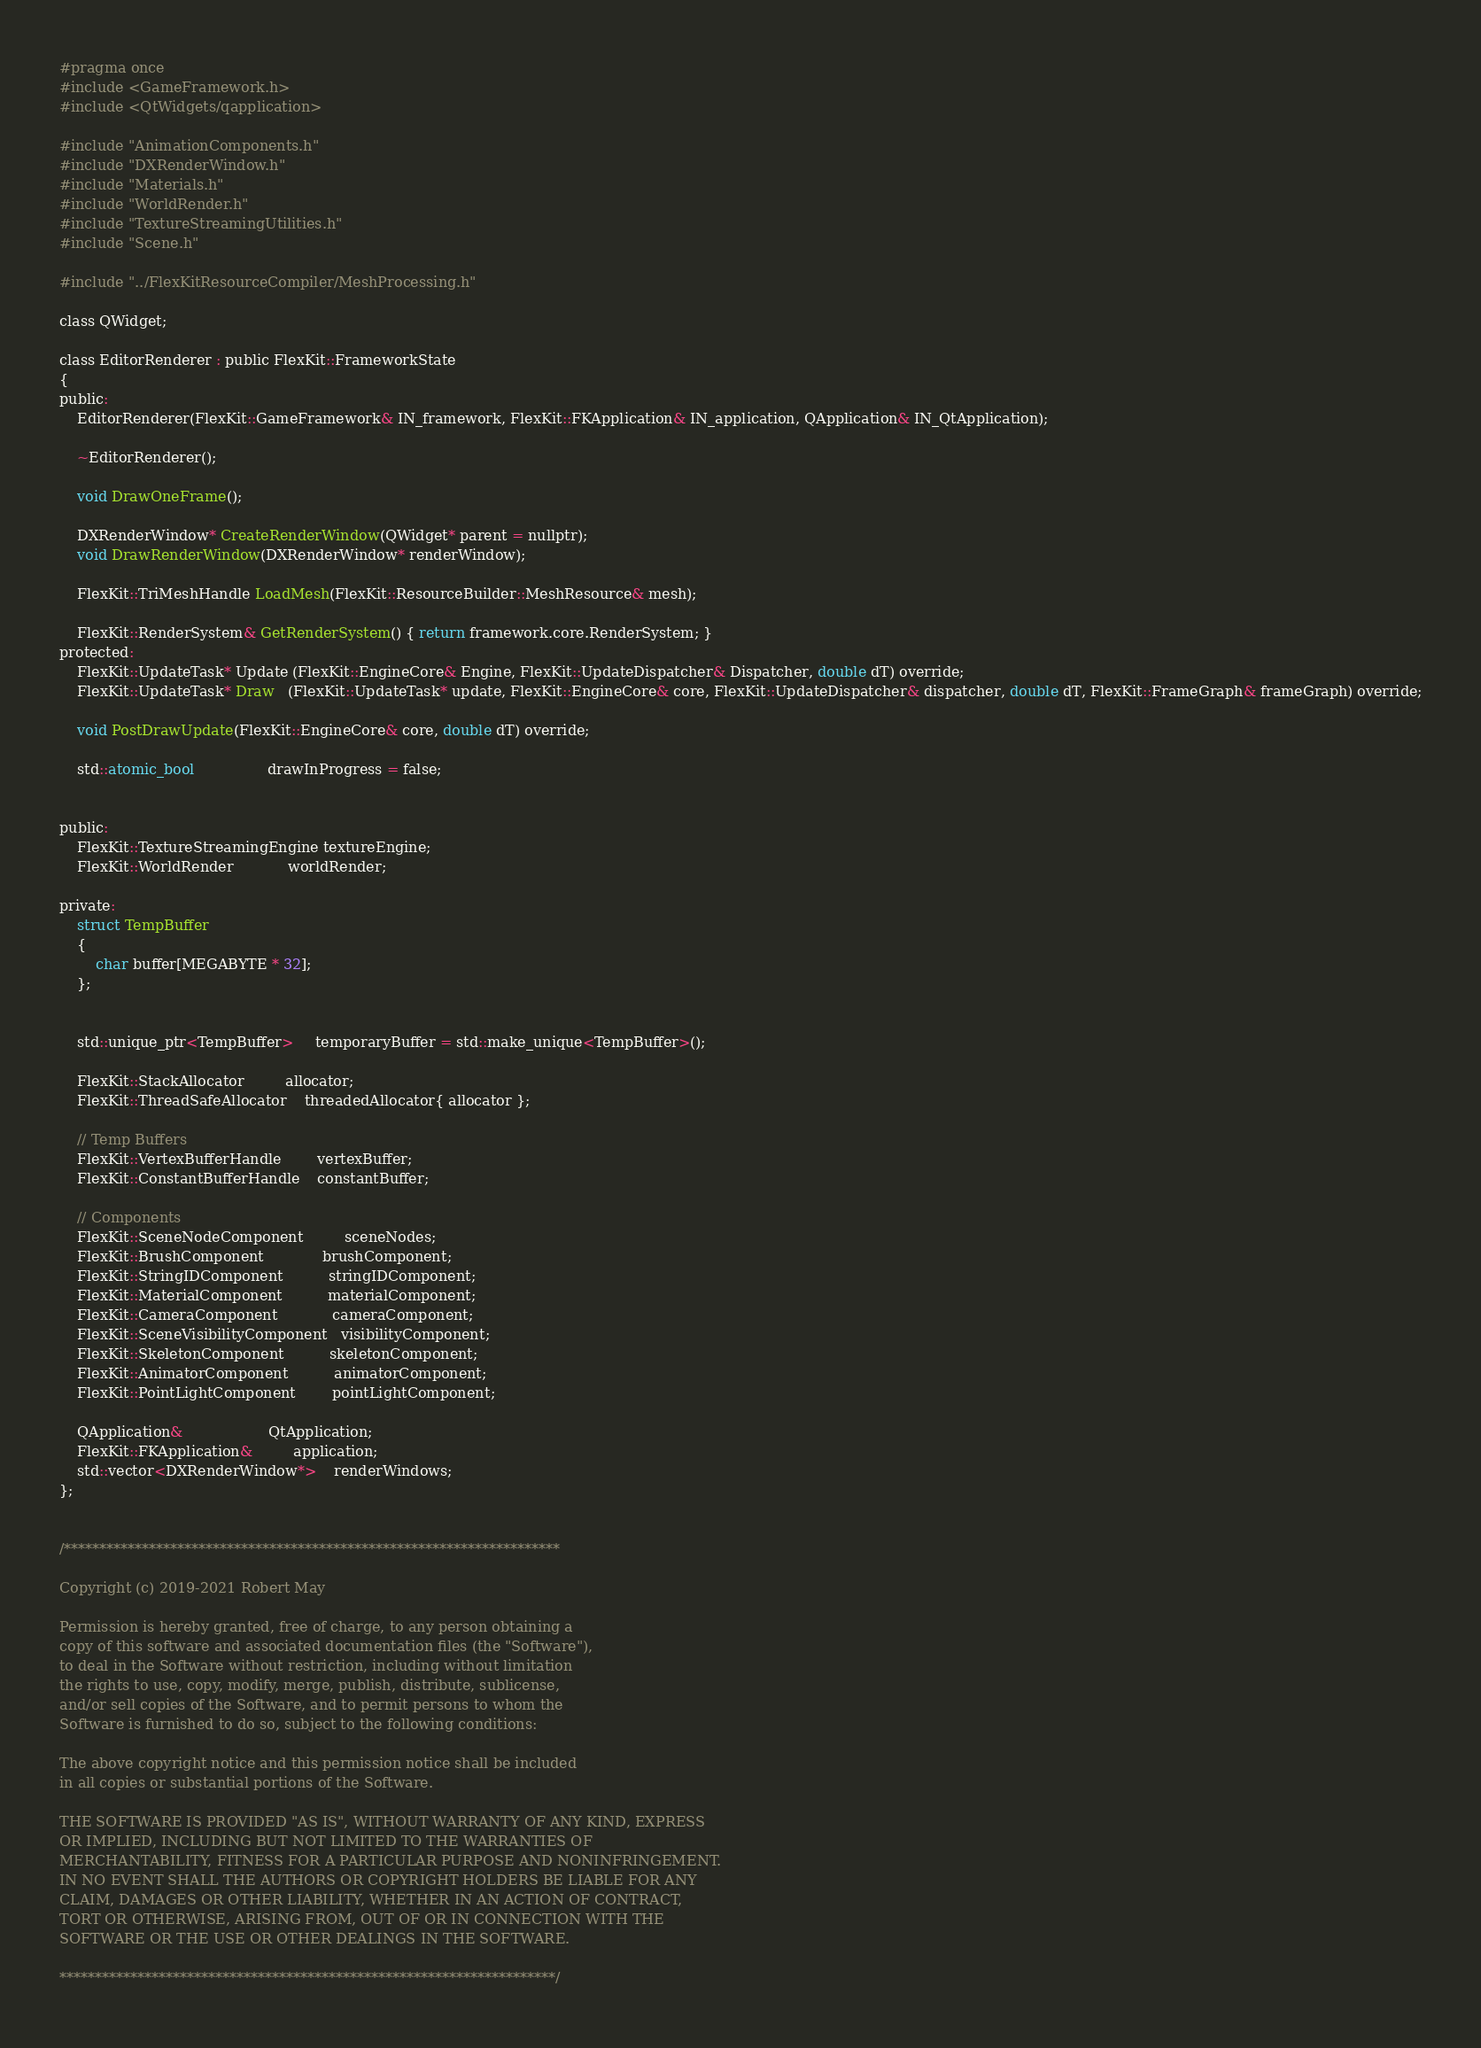<code> <loc_0><loc_0><loc_500><loc_500><_C_>#pragma once
#include <GameFramework.h>
#include <QtWidgets/qapplication>

#include "AnimationComponents.h"
#include "DXRenderWindow.h"
#include "Materials.h"
#include "WorldRender.h"
#include "TextureStreamingUtilities.h"
#include "Scene.h"

#include "../FlexKitResourceCompiler/MeshProcessing.h"

class QWidget;

class EditorRenderer : public FlexKit::FrameworkState
{
public:
    EditorRenderer(FlexKit::GameFramework& IN_framework, FlexKit::FKApplication& IN_application, QApplication& IN_QtApplication);

    ~EditorRenderer();

    void DrawOneFrame();

    DXRenderWindow* CreateRenderWindow(QWidget* parent = nullptr);
    void DrawRenderWindow(DXRenderWindow* renderWindow);

    FlexKit::TriMeshHandle LoadMesh(FlexKit::ResourceBuilder::MeshResource& mesh);

    FlexKit::RenderSystem& GetRenderSystem() { return framework.core.RenderSystem; }
protected:
    FlexKit::UpdateTask* Update (FlexKit::EngineCore& Engine, FlexKit::UpdateDispatcher& Dispatcher, double dT) override;
    FlexKit::UpdateTask* Draw   (FlexKit::UpdateTask* update, FlexKit::EngineCore& core, FlexKit::UpdateDispatcher& dispatcher, double dT, FlexKit::FrameGraph& frameGraph) override;

    void PostDrawUpdate(FlexKit::EngineCore& core, double dT) override;

    std::atomic_bool                drawInProgress = false;


public:
    FlexKit::TextureStreamingEngine textureEngine;
    FlexKit::WorldRender            worldRender;

private:
    struct TempBuffer
    {
        char buffer[MEGABYTE * 32];
    };


    std::unique_ptr<TempBuffer>     temporaryBuffer = std::make_unique<TempBuffer>();

    FlexKit::StackAllocator         allocator;
    FlexKit::ThreadSafeAllocator    threadedAllocator{ allocator };

    // Temp Buffers
    FlexKit::VertexBufferHandle		vertexBuffer;
    FlexKit::ConstantBufferHandle	constantBuffer;

    // Components
    FlexKit::SceneNodeComponent         sceneNodes;
    FlexKit::BrushComponent             brushComponent;
    FlexKit::StringIDComponent          stringIDComponent;
    FlexKit::MaterialComponent          materialComponent;
    FlexKit::CameraComponent            cameraComponent;
    FlexKit::SceneVisibilityComponent   visibilityComponent;
    FlexKit::SkeletonComponent          skeletonComponent;
    FlexKit::AnimatorComponent          animatorComponent;
    FlexKit::PointLightComponent        pointLightComponent;

    QApplication&                   QtApplication;
    FlexKit::FKApplication&         application;
    std::vector<DXRenderWindow*>    renderWindows;
};


/**********************************************************************

Copyright (c) 2019-2021 Robert May

Permission is hereby granted, free of charge, to any person obtaining a
copy of this software and associated documentation files (the "Software"),
to deal in the Software without restriction, including without limitation
the rights to use, copy, modify, merge, publish, distribute, sublicense,
and/or sell copies of the Software, and to permit persons to whom the
Software is furnished to do so, subject to the following conditions:

The above copyright notice and this permission notice shall be included
in all copies or substantial portions of the Software.

THE SOFTWARE IS PROVIDED "AS IS", WITHOUT WARRANTY OF ANY KIND, EXPRESS
OR IMPLIED, INCLUDING BUT NOT LIMITED TO THE WARRANTIES OF
MERCHANTABILITY, FITNESS FOR A PARTICULAR PURPOSE AND NONINFRINGEMENT.
IN NO EVENT SHALL THE AUTHORS OR COPYRIGHT HOLDERS BE LIABLE FOR ANY
CLAIM, DAMAGES OR OTHER LIABILITY, WHETHER IN AN ACTION OF CONTRACT,
TORT OR OTHERWISE, ARISING FROM, OUT OF OR IN CONNECTION WITH THE
SOFTWARE OR THE USE OR OTHER DEALINGS IN THE SOFTWARE.

**********************************************************************/
</code> 